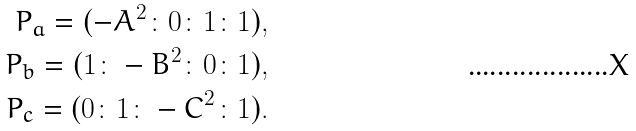Convert formula to latex. <formula><loc_0><loc_0><loc_500><loc_500>P _ { a } = ( - A ^ { 2 } \colon 0 \colon 1 \colon 1 ) , \\ P _ { b } = ( 1 \colon - B ^ { 2 } \colon 0 \colon 1 ) , \\ P _ { c } = ( 0 \colon 1 \colon - C ^ { 2 } \colon 1 ) .</formula> 